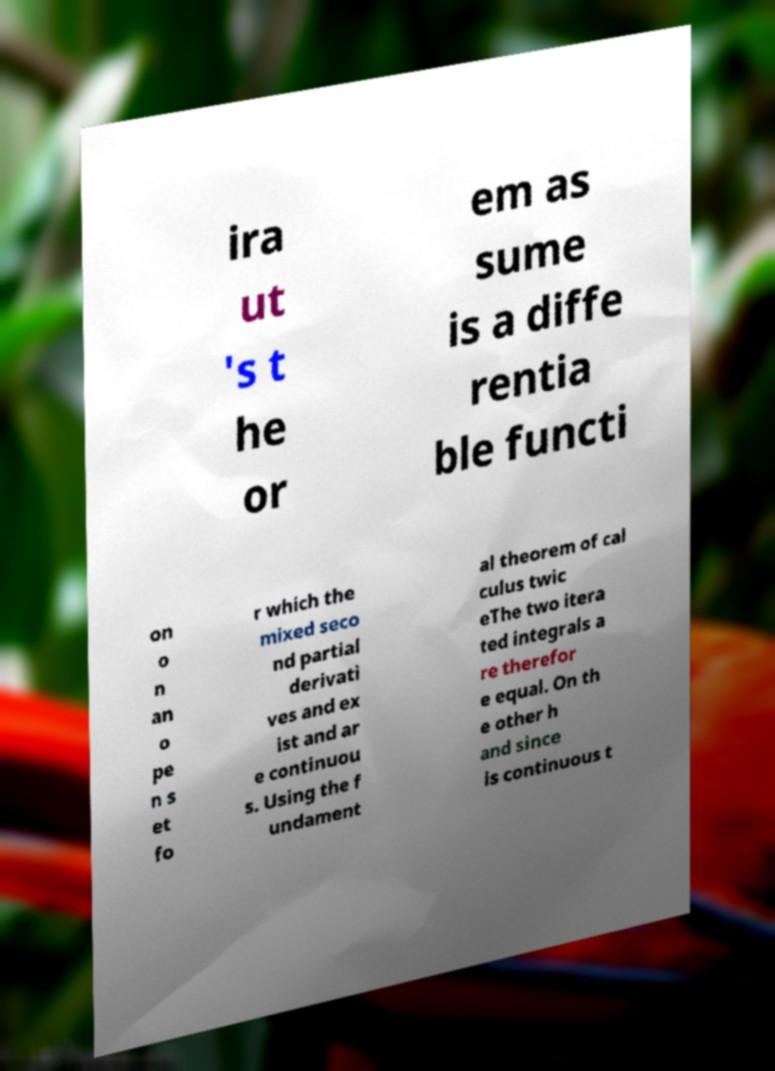Can you accurately transcribe the text from the provided image for me? ira ut 's t he or em as sume is a diffe rentia ble functi on o n an o pe n s et fo r which the mixed seco nd partial derivati ves and ex ist and ar e continuou s. Using the f undament al theorem of cal culus twic eThe two itera ted integrals a re therefor e equal. On th e other h and since is continuous t 